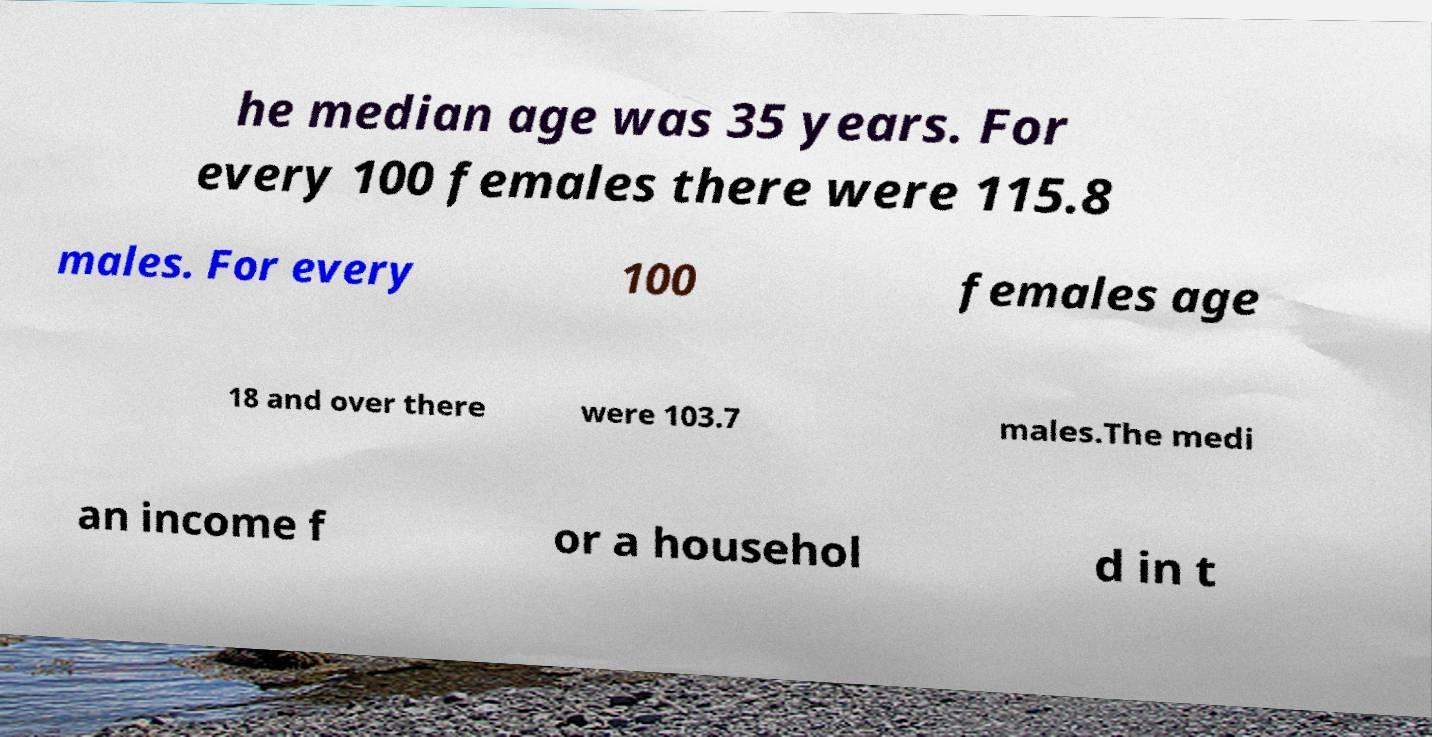What messages or text are displayed in this image? I need them in a readable, typed format. he median age was 35 years. For every 100 females there were 115.8 males. For every 100 females age 18 and over there were 103.7 males.The medi an income f or a househol d in t 